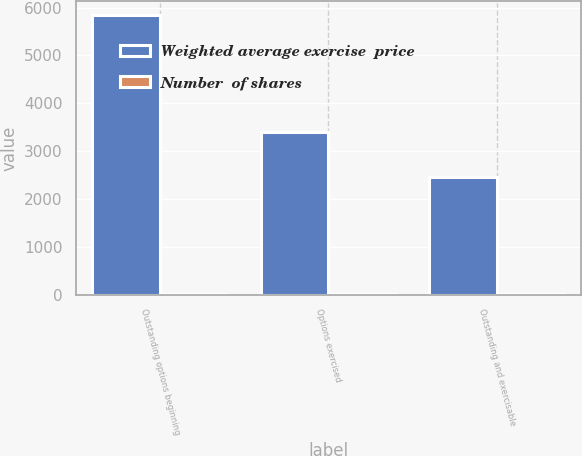Convert chart to OTSL. <chart><loc_0><loc_0><loc_500><loc_500><stacked_bar_chart><ecel><fcel>Outstanding options beginning<fcel>Options exercised<fcel>Outstanding and exercisable<nl><fcel>Weighted average exercise  price<fcel>5846<fcel>3392<fcel>2454<nl><fcel>Number  of shares<fcel>14.7<fcel>14.7<fcel>14.7<nl></chart> 